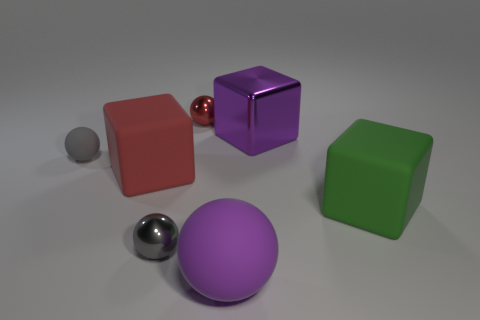Subtract all purple cubes. How many gray spheres are left? 2 Subtract all big green rubber cubes. How many cubes are left? 2 Subtract 2 balls. How many balls are left? 2 Subtract all purple spheres. How many spheres are left? 3 Add 3 cyan matte cylinders. How many objects exist? 10 Subtract all blue balls. Subtract all blue cubes. How many balls are left? 4 Subtract all blocks. How many objects are left? 4 Add 1 large yellow metal cylinders. How many large yellow metal cylinders exist? 1 Subtract 0 blue blocks. How many objects are left? 7 Subtract all large matte spheres. Subtract all big yellow matte cylinders. How many objects are left? 6 